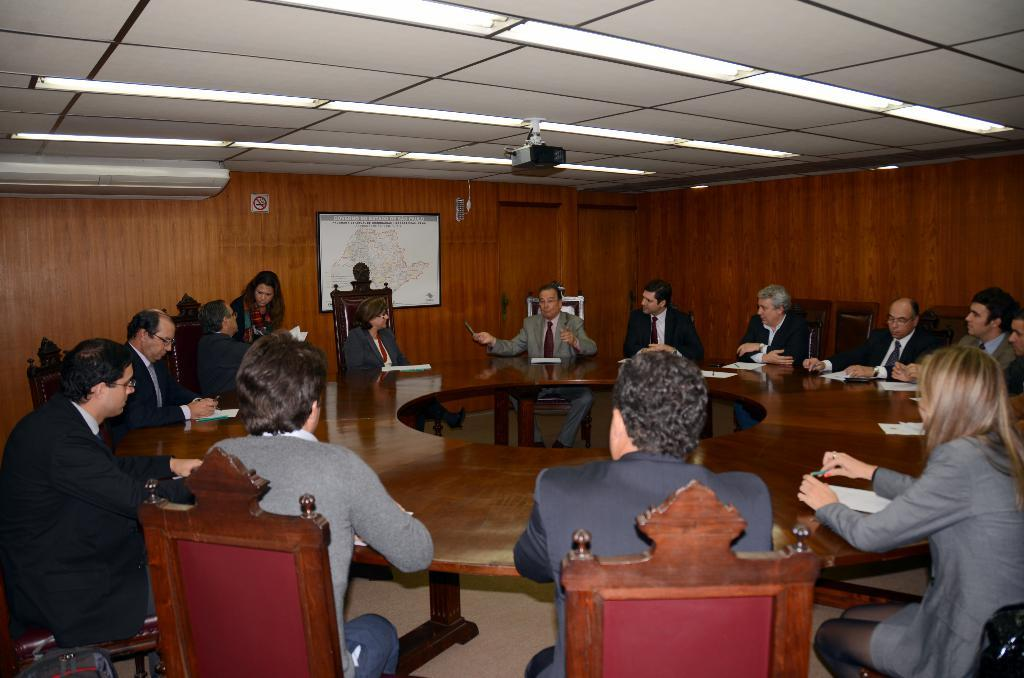What are the people in the image doing? The people in the image are sitting on chairs. What is the shape of the table in the image? The table in the image is round. What can be seen on the wall in the background of the image? There is a map on a wall in the background of the image. Can you tell me how many rifles are visible on the table in the image? There are no rifles present in the image; the table is round and has no visible objects on it. What color is the eye of the person sitting on the chair in the image? There is no mention of a person's eye in the image, as the focus is on the people sitting on chairs and the round table. 